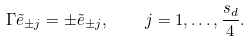Convert formula to latex. <formula><loc_0><loc_0><loc_500><loc_500>\Gamma \tilde { e } _ { \pm j } = \pm \tilde { e } _ { \pm j } , \quad j = 1 , \dots , \frac { s _ { d } } { 4 } .</formula> 